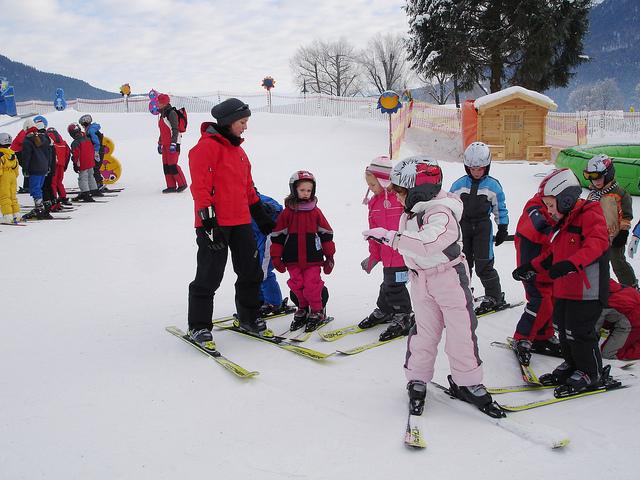Are all the children wearing helmets?
Short answer required. Yes. Is the pic taken during the day or night?
Short answer required. Day. Is the tallest person male or female?
Answer briefly. Female. What is the place these people are at called?
Be succinct. Ski resort. How cold is it there?
Keep it brief. Very. How deep is the snow?
Short answer required. 3 inches. 